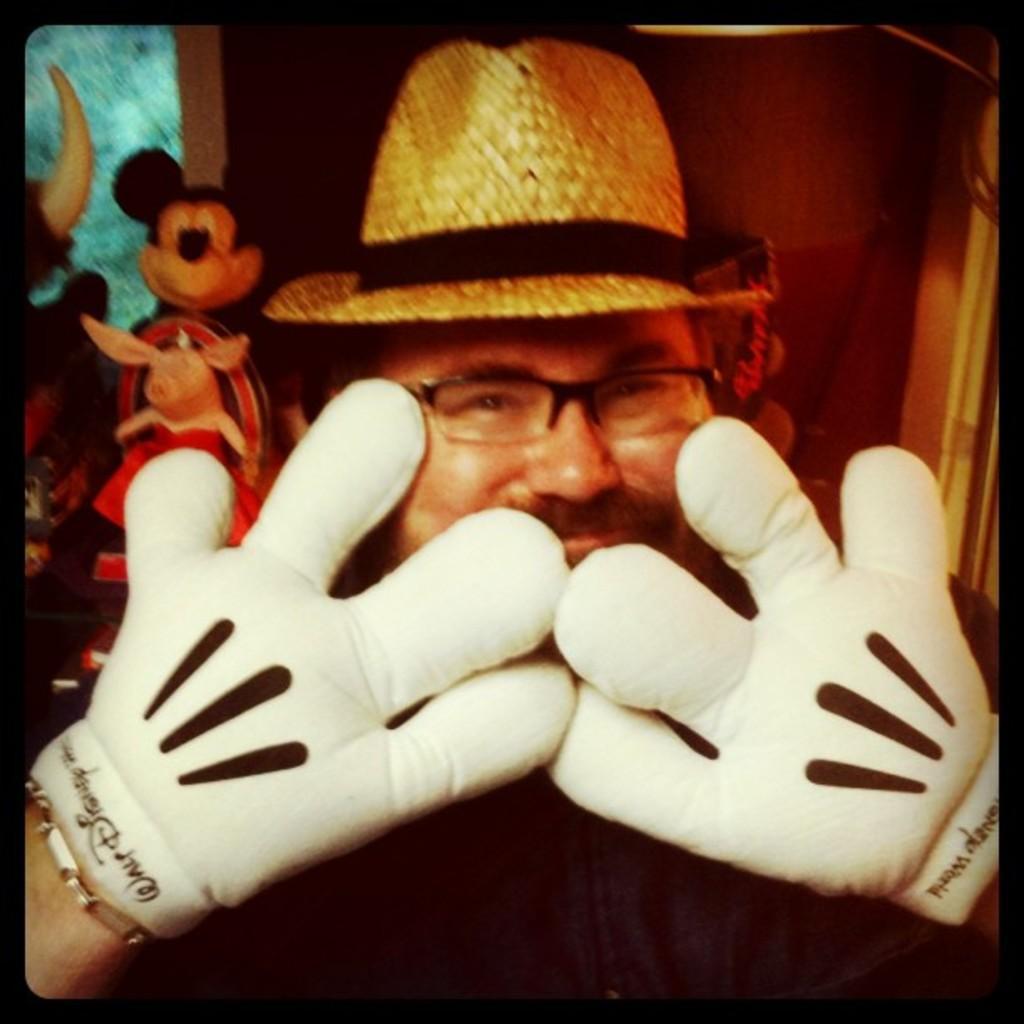Can you describe this image briefly? In this picture there is a man wearing white color gloves in the hand and cow boy cap, smiling and giving a pose into the camera. Behind there is a mickey mouse toys and brown color wall. 